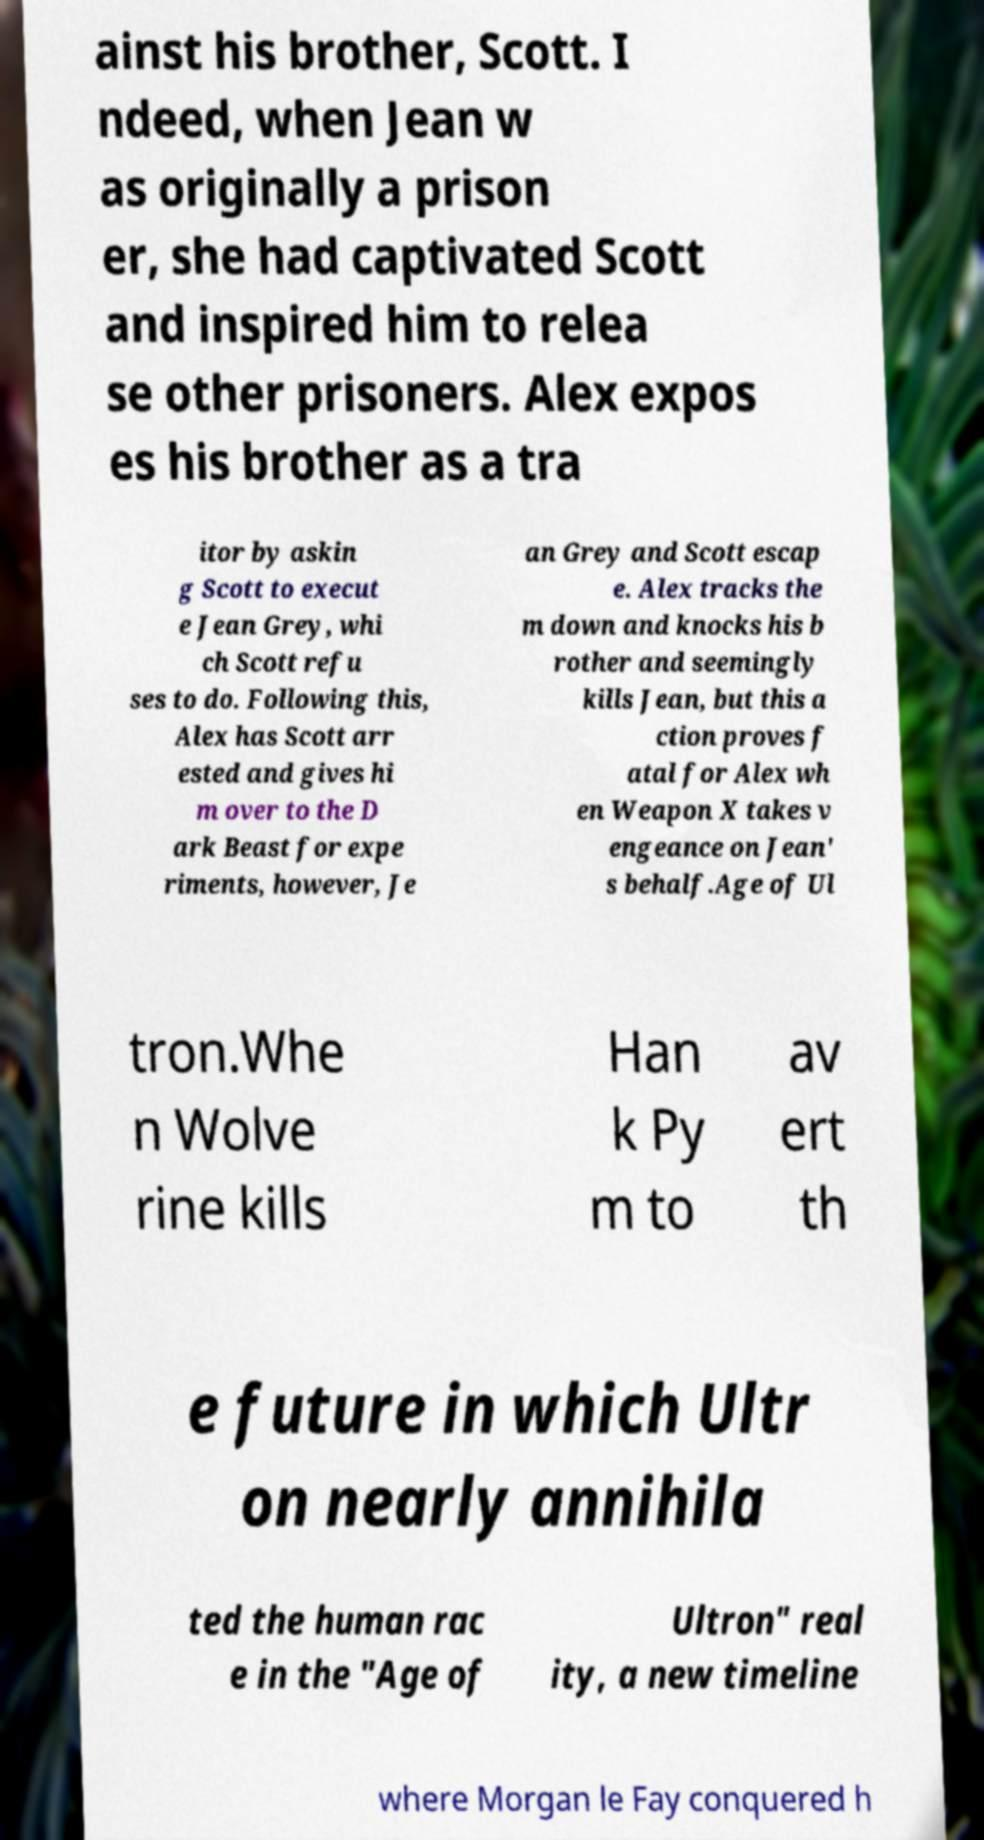Please identify and transcribe the text found in this image. ainst his brother, Scott. I ndeed, when Jean w as originally a prison er, she had captivated Scott and inspired him to relea se other prisoners. Alex expos es his brother as a tra itor by askin g Scott to execut e Jean Grey, whi ch Scott refu ses to do. Following this, Alex has Scott arr ested and gives hi m over to the D ark Beast for expe riments, however, Je an Grey and Scott escap e. Alex tracks the m down and knocks his b rother and seemingly kills Jean, but this a ction proves f atal for Alex wh en Weapon X takes v engeance on Jean' s behalf.Age of Ul tron.Whe n Wolve rine kills Han k Py m to av ert th e future in which Ultr on nearly annihila ted the human rac e in the "Age of Ultron" real ity, a new timeline where Morgan le Fay conquered h 